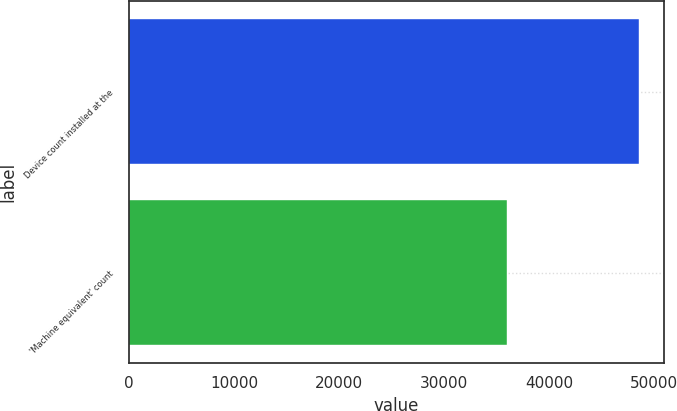<chart> <loc_0><loc_0><loc_500><loc_500><bar_chart><fcel>Device count installed at the<fcel>'Machine equivalent' count<nl><fcel>48545<fcel>35997<nl></chart> 